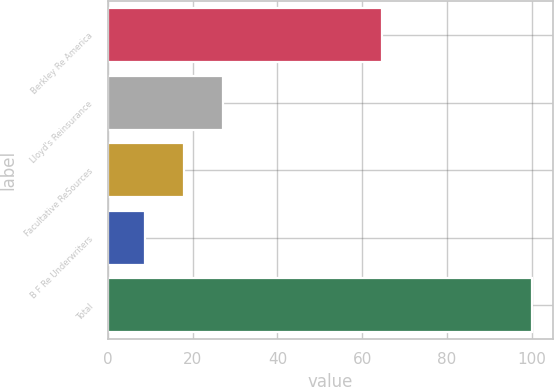Convert chart. <chart><loc_0><loc_0><loc_500><loc_500><bar_chart><fcel>Berkley Re America<fcel>Lloyd's Reinsurance<fcel>Facultative ReSources<fcel>B F Re Underwriters<fcel>Total<nl><fcel>64.6<fcel>27.04<fcel>17.92<fcel>8.8<fcel>100<nl></chart> 